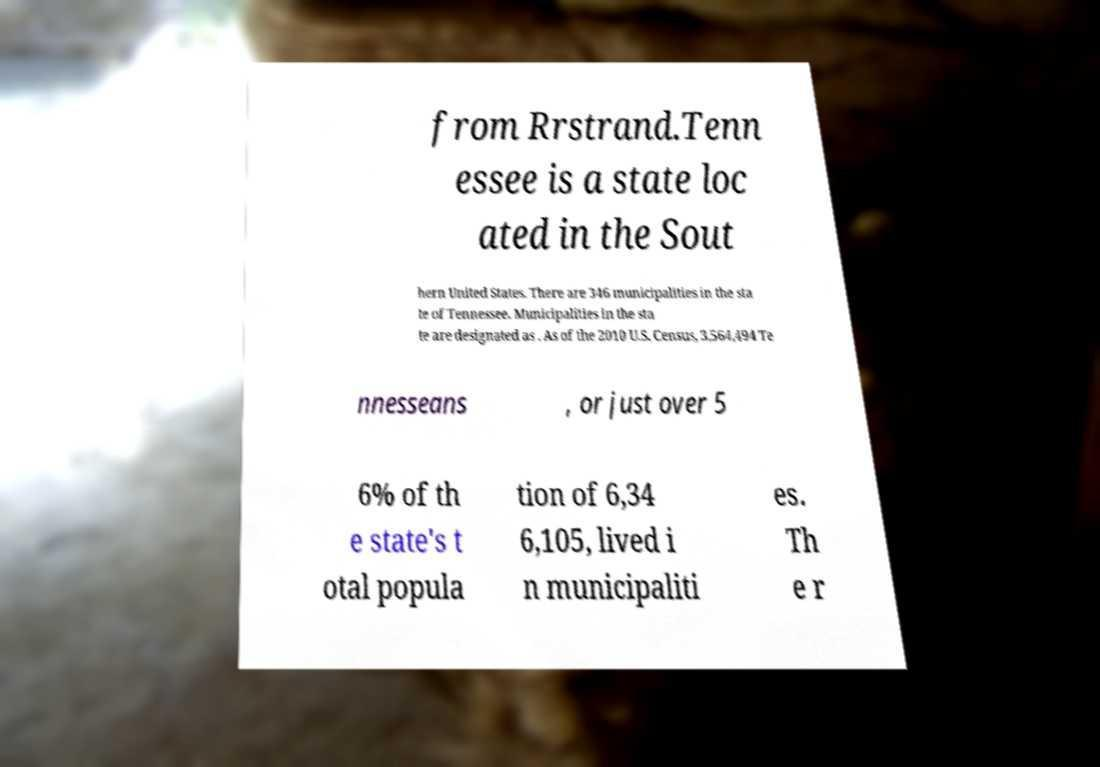Can you accurately transcribe the text from the provided image for me? from Rrstrand.Tenn essee is a state loc ated in the Sout hern United States. There are 346 municipalities in the sta te of Tennessee. Municipalities in the sta te are designated as . As of the 2010 U.S. Census, 3,564,494 Te nnesseans , or just over 5 6% of th e state's t otal popula tion of 6,34 6,105, lived i n municipaliti es. Th e r 